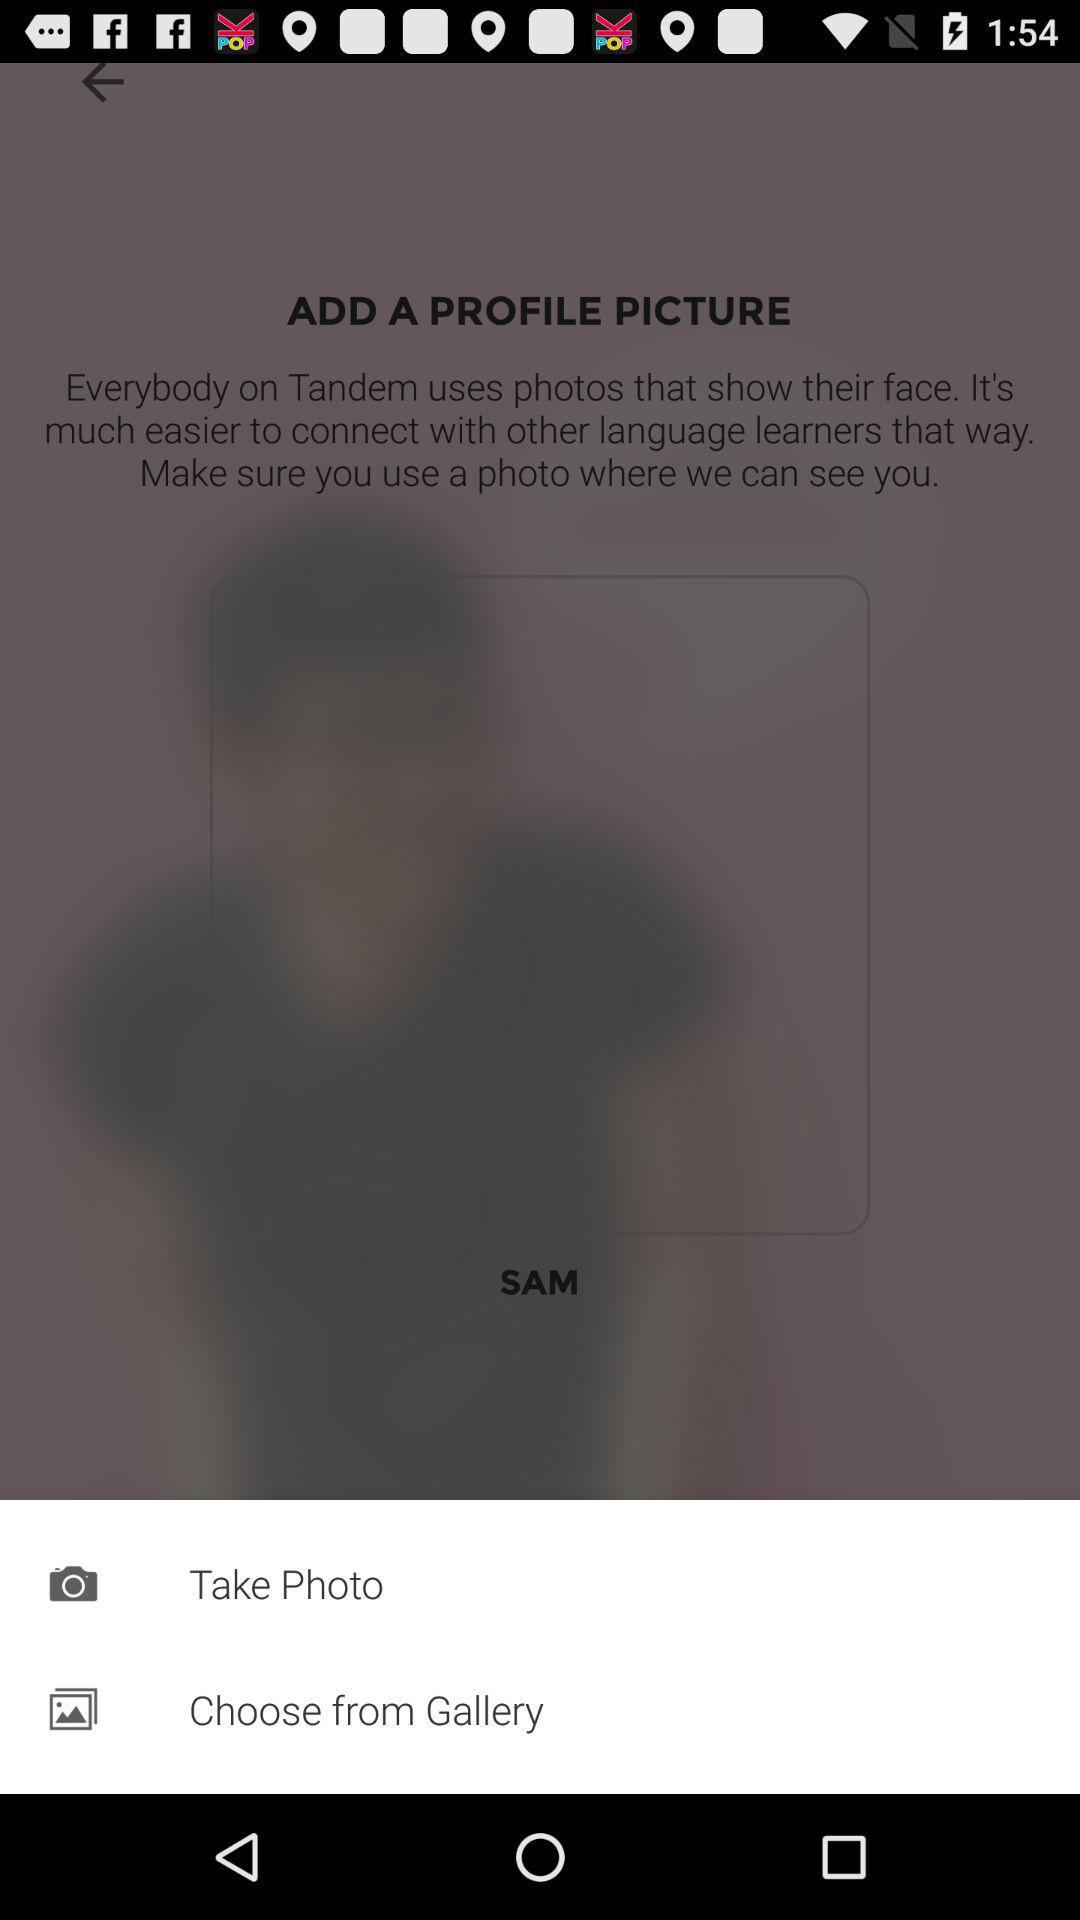How many ways can I add a profile picture?
Answer the question using a single word or phrase. 2 